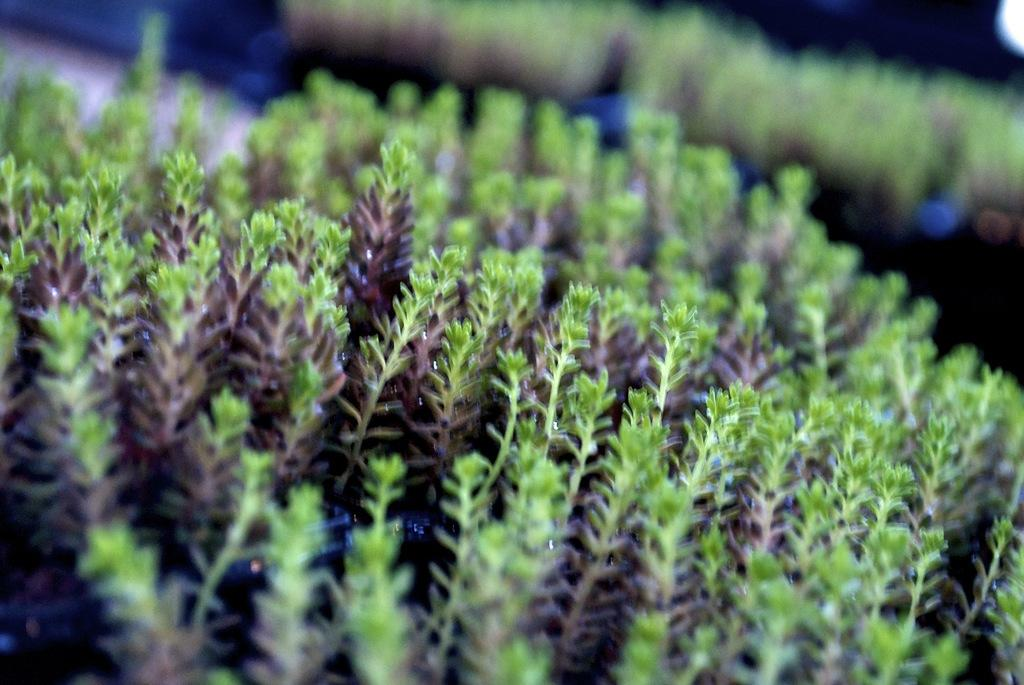What type of living organisms can be seen in the image? Plants can be seen in the image. What type of snack is being prepared in the image? There is no snack preparation visible in the image; it only features plants. Is there a gate present in the image? There is no gate present in the image; it only features plants. Can you identify any boundaries or borders in the image? There is no mention of boundaries or borders in the image; it only features plants. 